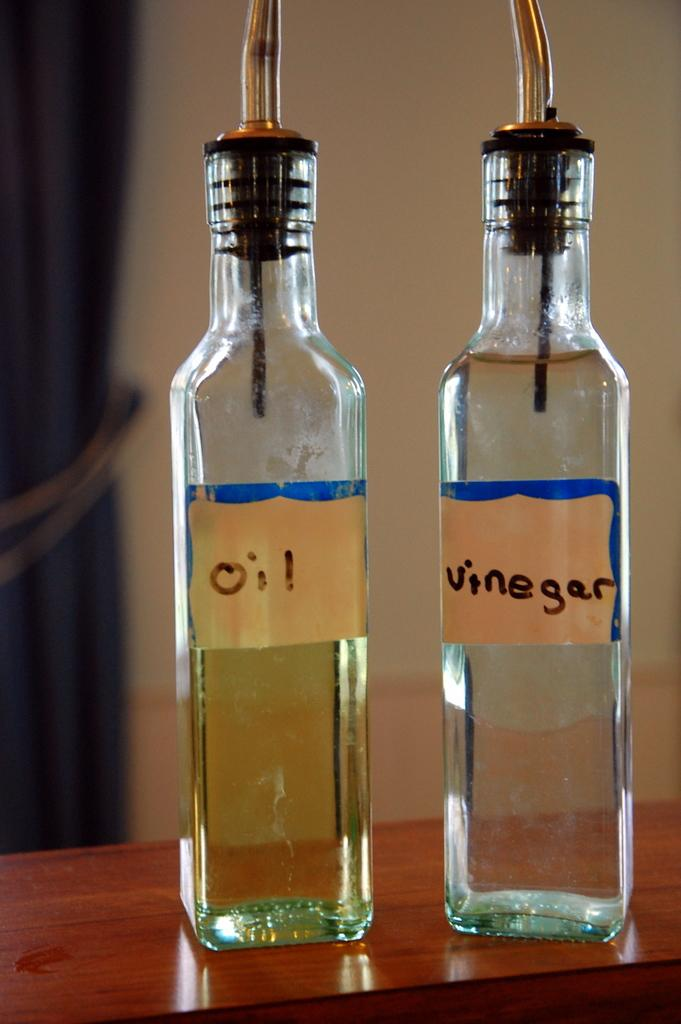Provide a one-sentence caption for the provided image. Bottle of oil next to a bottle of vinegar. 